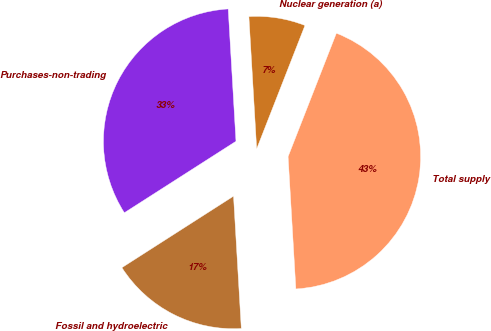<chart> <loc_0><loc_0><loc_500><loc_500><pie_chart><fcel>Nuclear generation (a)<fcel>Purchases-non-trading<fcel>Fossil and hydroelectric<fcel>Total supply<nl><fcel>6.87%<fcel>33.13%<fcel>16.87%<fcel>43.13%<nl></chart> 